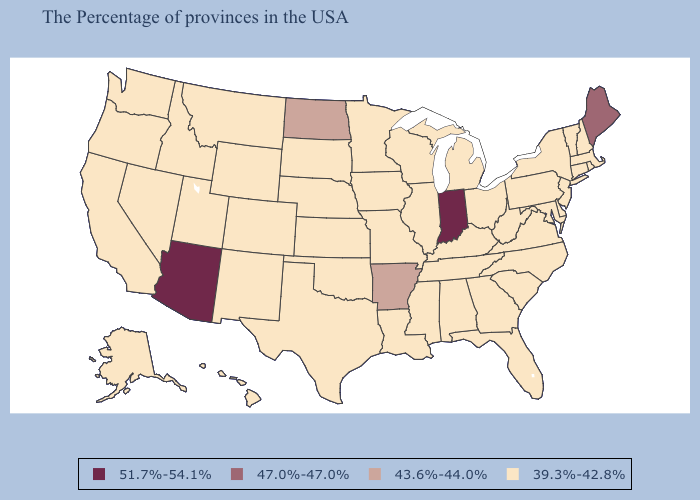Is the legend a continuous bar?
Write a very short answer. No. Which states hav the highest value in the West?
Keep it brief. Arizona. Does Michigan have the same value as Arkansas?
Write a very short answer. No. Which states have the highest value in the USA?
Keep it brief. Indiana, Arizona. What is the lowest value in the USA?
Write a very short answer. 39.3%-42.8%. Which states have the highest value in the USA?
Quick response, please. Indiana, Arizona. Does Massachusetts have the same value as West Virginia?
Quick response, please. Yes. What is the value of North Carolina?
Short answer required. 39.3%-42.8%. How many symbols are there in the legend?
Answer briefly. 4. How many symbols are there in the legend?
Concise answer only. 4. What is the value of Maryland?
Give a very brief answer. 39.3%-42.8%. What is the value of Alaska?
Answer briefly. 39.3%-42.8%. Does Connecticut have the highest value in the Northeast?
Write a very short answer. No. Name the states that have a value in the range 51.7%-54.1%?
Write a very short answer. Indiana, Arizona. 